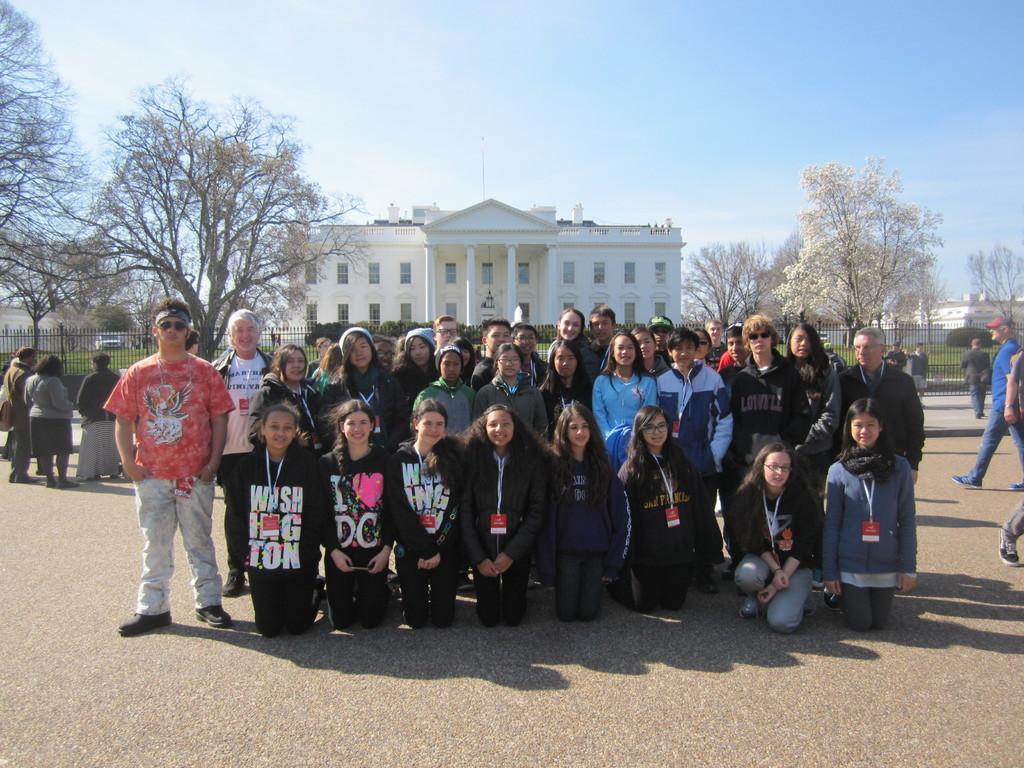Could you give a brief overview of what you see in this image? In this image we can see a few people, there are some buildings, trees, vehicles, grass, windows and the fence, in the background, we can see the sky. 